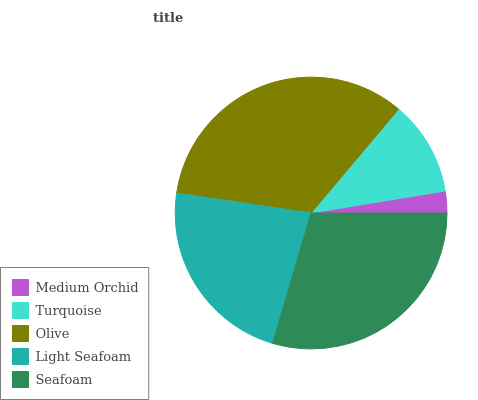Is Medium Orchid the minimum?
Answer yes or no. Yes. Is Olive the maximum?
Answer yes or no. Yes. Is Turquoise the minimum?
Answer yes or no. No. Is Turquoise the maximum?
Answer yes or no. No. Is Turquoise greater than Medium Orchid?
Answer yes or no. Yes. Is Medium Orchid less than Turquoise?
Answer yes or no. Yes. Is Medium Orchid greater than Turquoise?
Answer yes or no. No. Is Turquoise less than Medium Orchid?
Answer yes or no. No. Is Light Seafoam the high median?
Answer yes or no. Yes. Is Light Seafoam the low median?
Answer yes or no. Yes. Is Turquoise the high median?
Answer yes or no. No. Is Medium Orchid the low median?
Answer yes or no. No. 